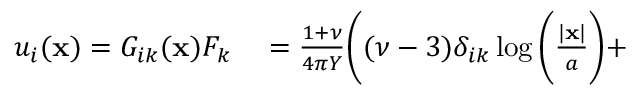<formula> <loc_0><loc_0><loc_500><loc_500>\begin{array} { r l } { u _ { i } ( { x } ) = G _ { i k } ( x ) F _ { k } } & = \frac { 1 + \nu } { 4 \pi Y } \Big ( ( \nu - 3 ) \delta _ { i k } \log \Big ( \frac { | x | } { a } \Big ) + } \end{array}</formula> 